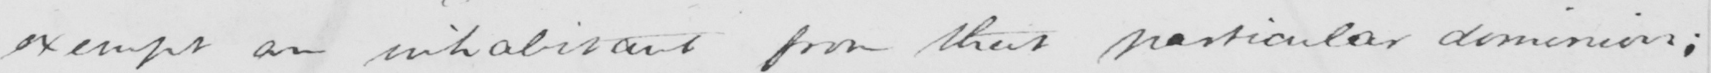Please transcribe the handwritten text in this image. exempt an inhabitant from that particular dominion ; 